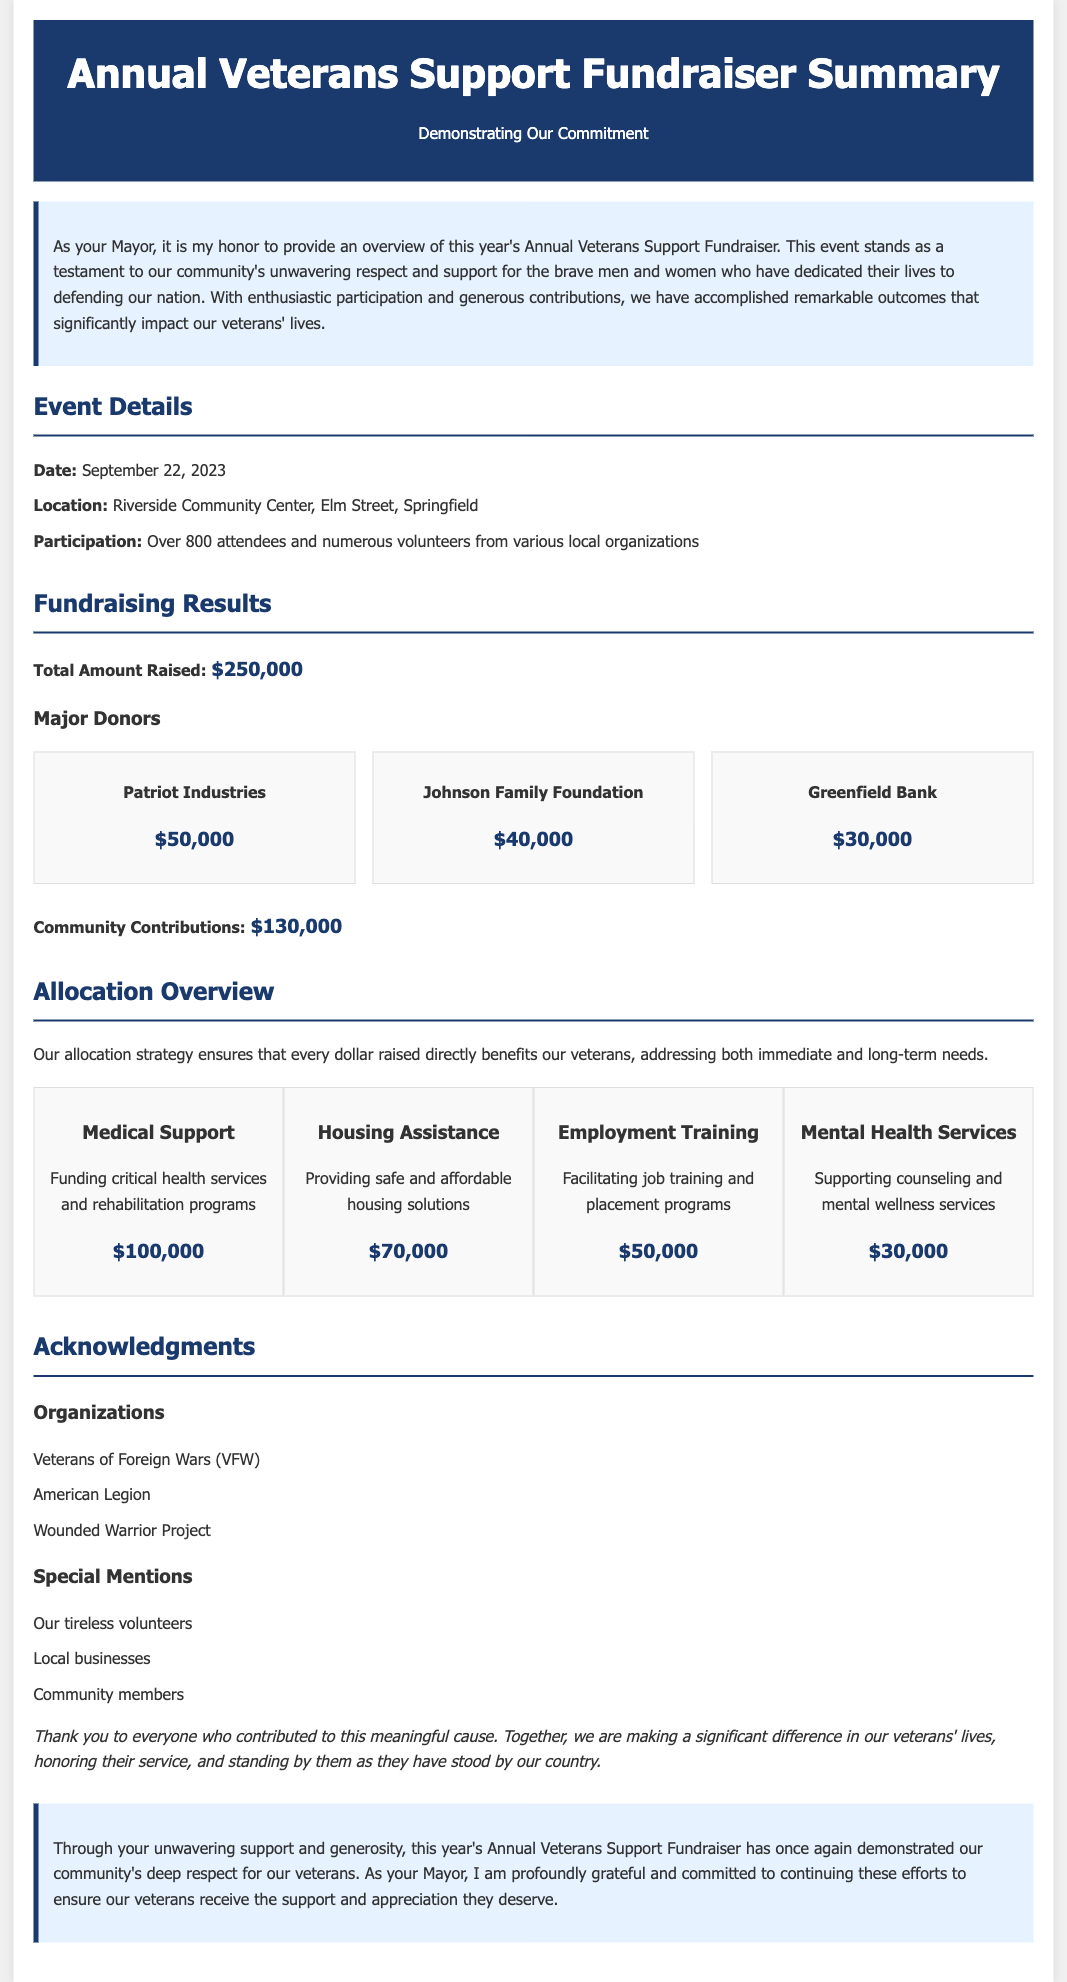What was the total amount raised during the fundraiser? The total amount raised is provided directly in the document as part of the fundraising results section.
Answer: $250,000 When was the event held? The specific date of the event is mentioned in the event details section.
Answer: September 22, 2023 What was the location of the fundraiser? The location of the event is stated in the event details section.
Answer: Riverside Community Center, Elm Street, Springfield Which organization contributed the most? The major donors list indicates which organization made the largest contribution.
Answer: Patriot Industries How much funding was allocated for medical support? This information is detailed in the allocation overview section under medical support.
Answer: $100,000 What percentage of the total amount raised came from community contributions? Reasoning involves calculating the percentage using the total amount raised and community contributions listed in the document.
Answer: 52% What are the four areas for fund allocation? The document explicitly lists the areas where funds are allocated in the allocation overview section.
Answer: Medical Support, Housing Assistance, Employment Training, Mental Health Services Who were acknowledged for their contributions? The acknowledgment section lists the organizations and special mentions.
Answer: Veterans of Foreign Wars (VFW), American Legion, Wounded Warrior Project What is the main goal of this fundraiser? The introductory section outlines the overarching objective of the event.
Answer: Supporting veterans 